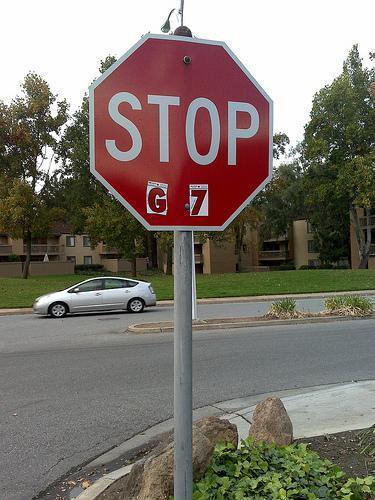How many cars are in the photo?
Give a very brief answer. 1. 